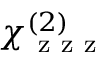<formula> <loc_0><loc_0><loc_500><loc_500>\chi _ { z z z } ^ { ( 2 ) }</formula> 